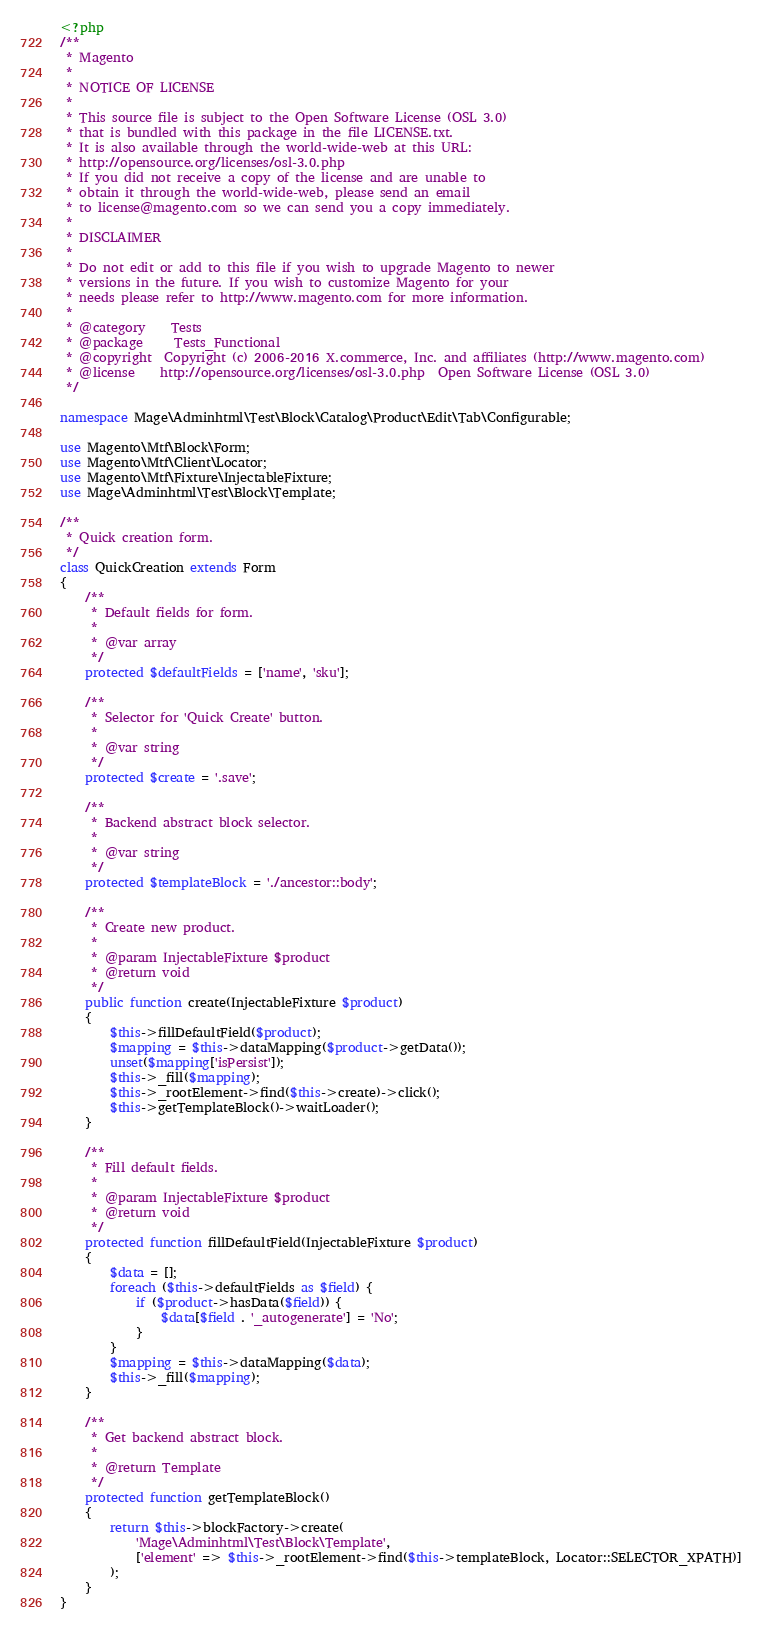<code> <loc_0><loc_0><loc_500><loc_500><_PHP_><?php
/**
 * Magento
 *
 * NOTICE OF LICENSE
 *
 * This source file is subject to the Open Software License (OSL 3.0)
 * that is bundled with this package in the file LICENSE.txt.
 * It is also available through the world-wide-web at this URL:
 * http://opensource.org/licenses/osl-3.0.php
 * If you did not receive a copy of the license and are unable to
 * obtain it through the world-wide-web, please send an email
 * to license@magento.com so we can send you a copy immediately.
 *
 * DISCLAIMER
 *
 * Do not edit or add to this file if you wish to upgrade Magento to newer
 * versions in the future. If you wish to customize Magento for your
 * needs please refer to http://www.magento.com for more information.
 *
 * @category    Tests
 * @package     Tests_Functional
 * @copyright  Copyright (c) 2006-2016 X.commerce, Inc. and affiliates (http://www.magento.com)
 * @license    http://opensource.org/licenses/osl-3.0.php  Open Software License (OSL 3.0)
 */

namespace Mage\Adminhtml\Test\Block\Catalog\Product\Edit\Tab\Configurable;

use Magento\Mtf\Block\Form;
use Magento\Mtf\Client\Locator;
use Magento\Mtf\Fixture\InjectableFixture;
use Mage\Adminhtml\Test\Block\Template;

/**
 * Quick creation form.
 */
class QuickCreation extends Form
{
    /**
     * Default fields for form.
     *
     * @var array
     */
    protected $defaultFields = ['name', 'sku'];

    /**
     * Selector for 'Quick Create' button.
     *
     * @var string
     */
    protected $create = '.save';

    /**
     * Backend abstract block selector.
     *
     * @var string
     */
    protected $templateBlock = './ancestor::body';

    /**
     * Create new product.
     *
     * @param InjectableFixture $product
     * @return void
     */
    public function create(InjectableFixture $product)
    {
        $this->fillDefaultField($product);
        $mapping = $this->dataMapping($product->getData());
        unset($mapping['isPersist']);
        $this->_fill($mapping);
        $this->_rootElement->find($this->create)->click();
        $this->getTemplateBlock()->waitLoader();
    }

    /**
     * Fill default fields.
     *
     * @param InjectableFixture $product
     * @return void
     */
    protected function fillDefaultField(InjectableFixture $product)
    {
        $data = [];
        foreach ($this->defaultFields as $field) {
            if ($product->hasData($field)) {
                $data[$field . '_autogenerate'] = 'No';
            }
        }
        $mapping = $this->dataMapping($data);
        $this->_fill($mapping);
    }

    /**
     * Get backend abstract block.
     *
     * @return Template
     */
    protected function getTemplateBlock()
    {
        return $this->blockFactory->create(
            'Mage\Adminhtml\Test\Block\Template',
            ['element' => $this->_rootElement->find($this->templateBlock, Locator::SELECTOR_XPATH)]
        );
    }
}
</code> 